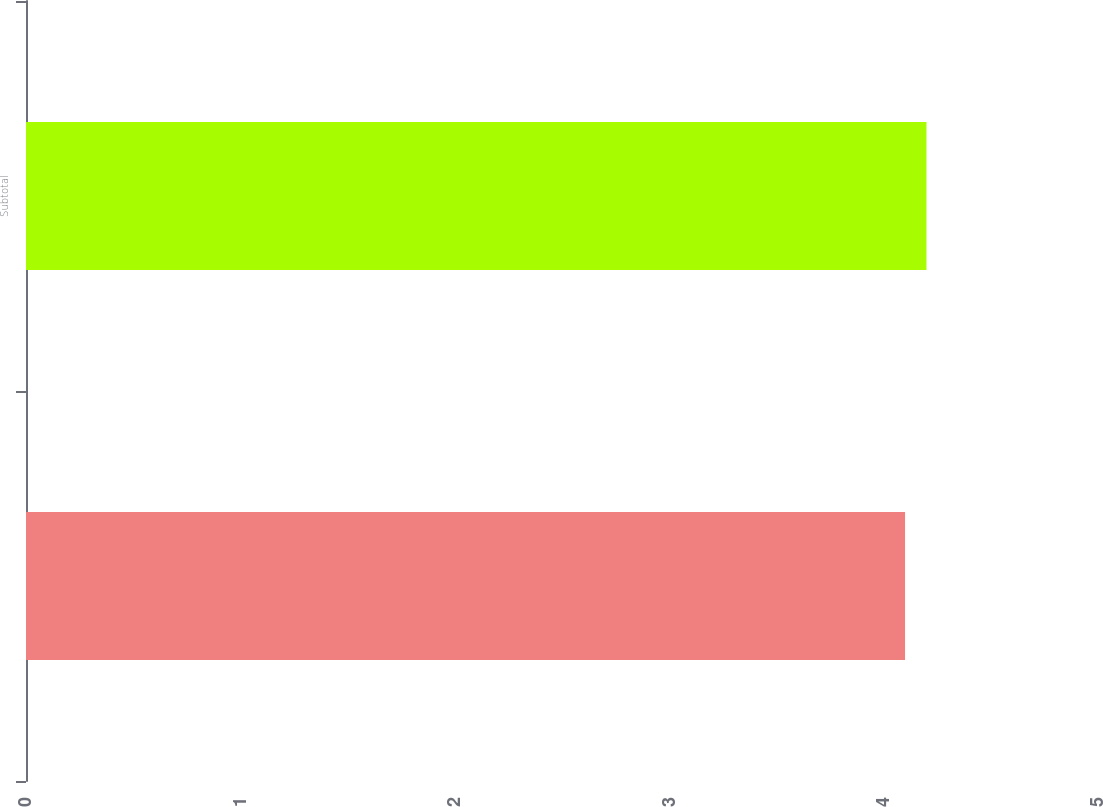Convert chart. <chart><loc_0><loc_0><loc_500><loc_500><bar_chart><ecel><fcel>Subtotal<nl><fcel>4.1<fcel>4.2<nl></chart> 